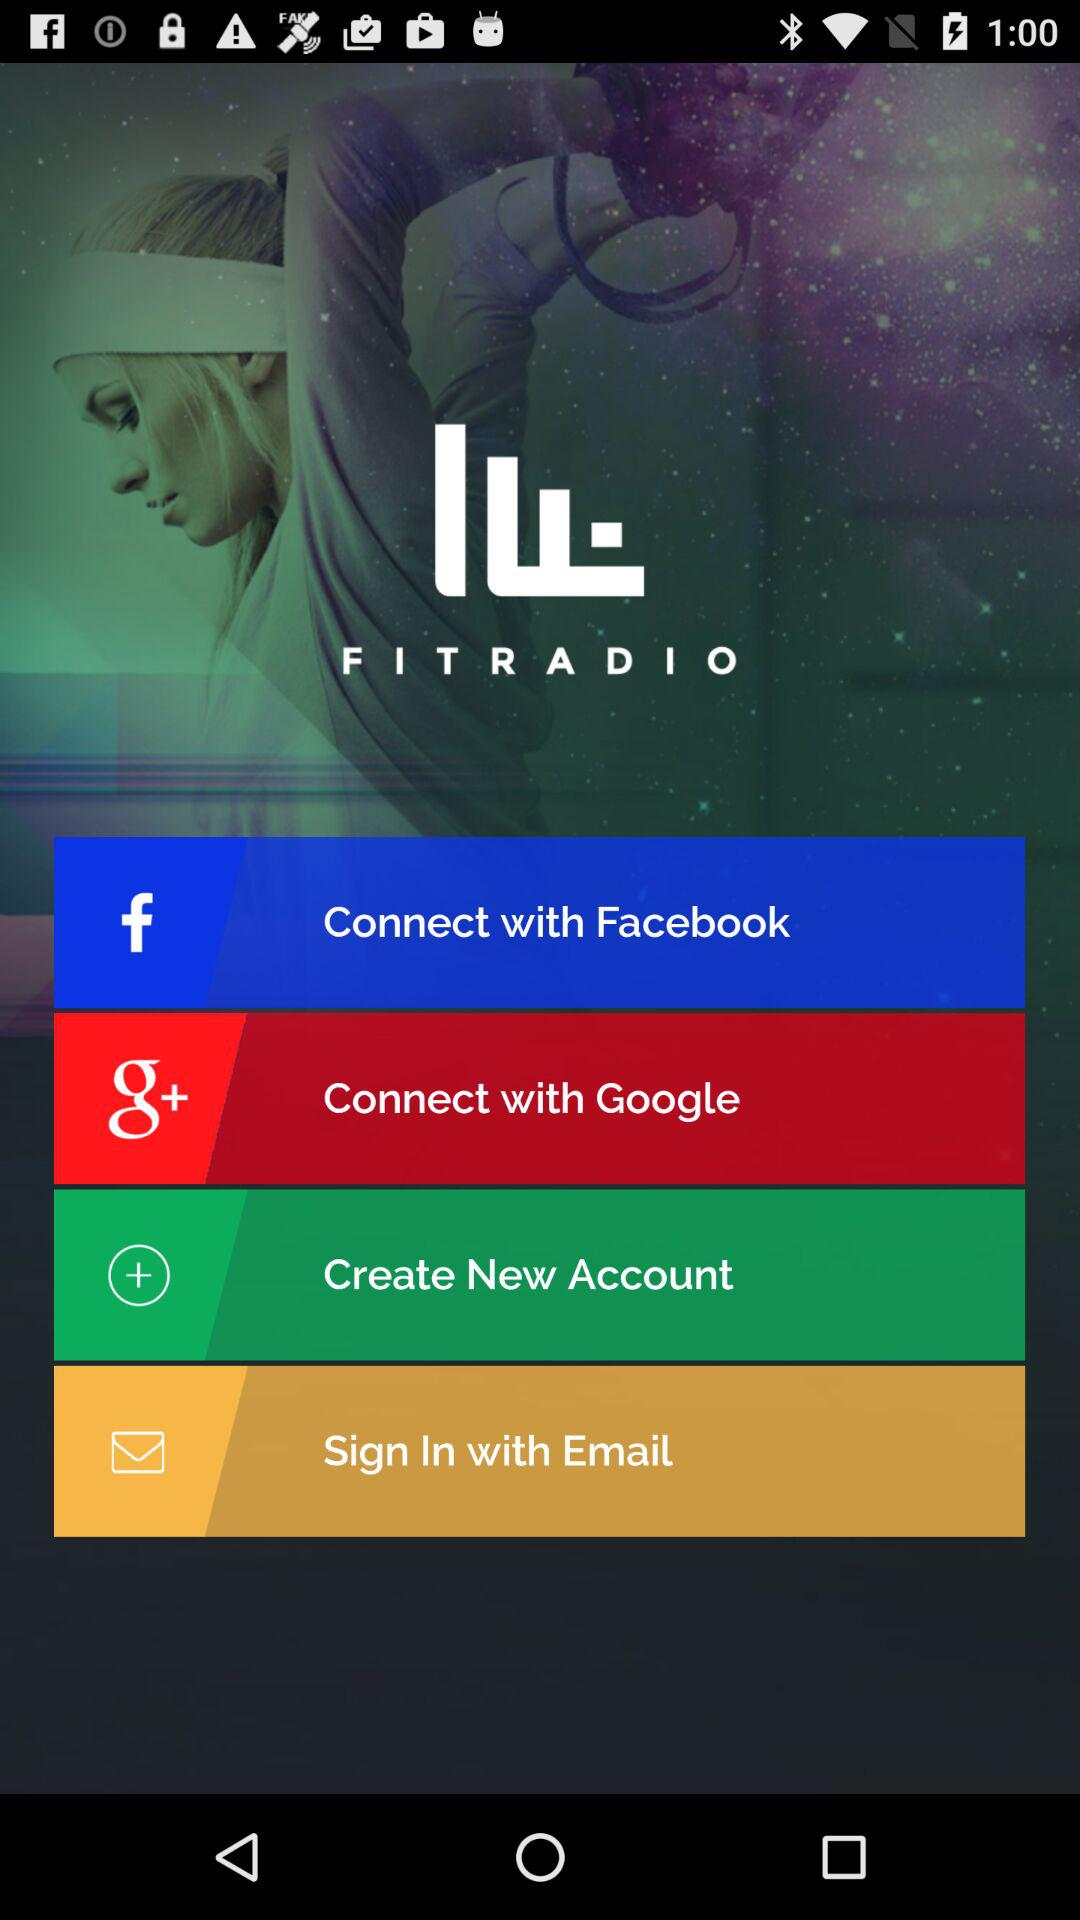What accounts can I use to sign up? You can sign up with "Facebook", "Google", and "Email". 